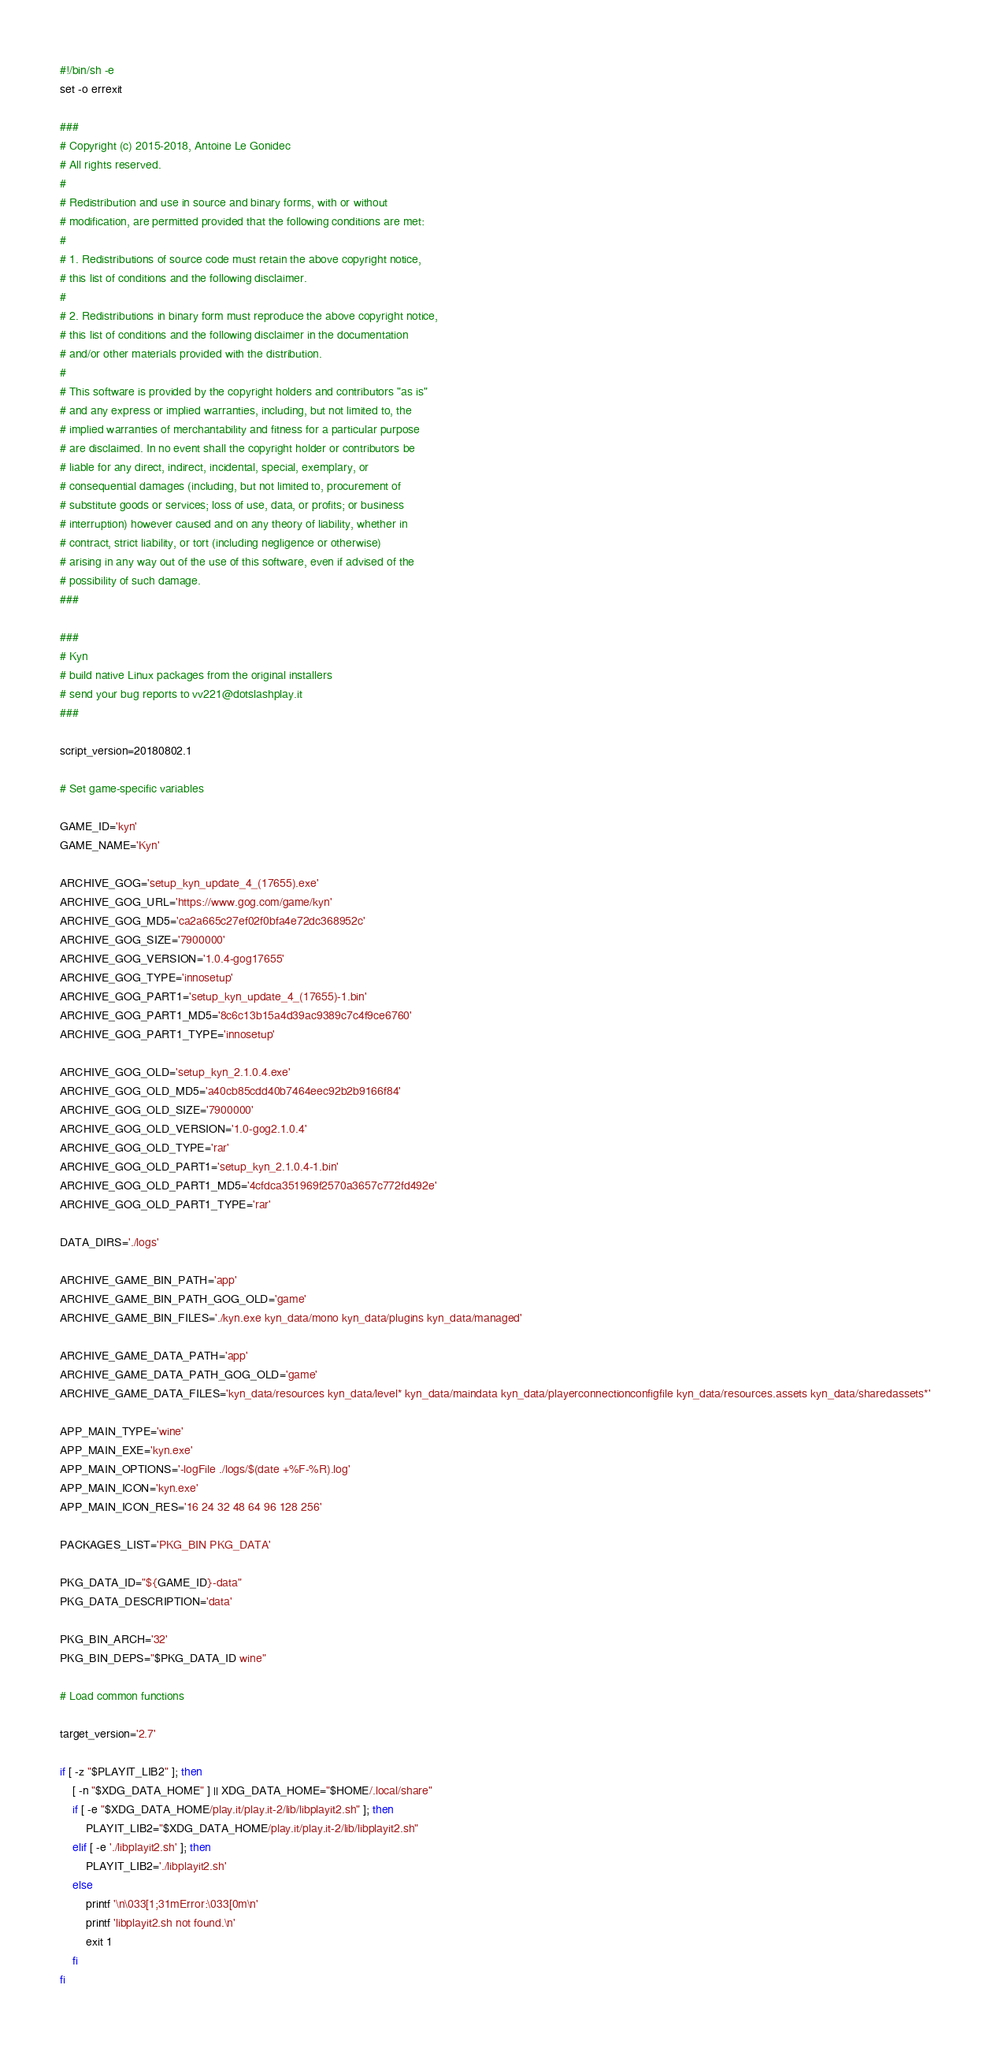<code> <loc_0><loc_0><loc_500><loc_500><_Bash_>#!/bin/sh -e
set -o errexit

###
# Copyright (c) 2015-2018, Antoine Le Gonidec
# All rights reserved.
#
# Redistribution and use in source and binary forms, with or without
# modification, are permitted provided that the following conditions are met:
#
# 1. Redistributions of source code must retain the above copyright notice,
# this list of conditions and the following disclaimer.
#
# 2. Redistributions in binary form must reproduce the above copyright notice,
# this list of conditions and the following disclaimer in the documentation
# and/or other materials provided with the distribution.
#
# This software is provided by the copyright holders and contributors "as is"
# and any express or implied warranties, including, but not limited to, the
# implied warranties of merchantability and fitness for a particular purpose
# are disclaimed. In no event shall the copyright holder or contributors be
# liable for any direct, indirect, incidental, special, exemplary, or
# consequential damages (including, but not limited to, procurement of
# substitute goods or services; loss of use, data, or profits; or business
# interruption) however caused and on any theory of liability, whether in
# contract, strict liability, or tort (including negligence or otherwise)
# arising in any way out of the use of this software, even if advised of the
# possibility of such damage.
###

###
# Kyn
# build native Linux packages from the original installers
# send your bug reports to vv221@dotslashplay.it
###

script_version=20180802.1

# Set game-specific variables

GAME_ID='kyn'
GAME_NAME='Kyn'

ARCHIVE_GOG='setup_kyn_update_4_(17655).exe'
ARCHIVE_GOG_URL='https://www.gog.com/game/kyn'
ARCHIVE_GOG_MD5='ca2a665c27ef02f0bfa4e72dc368952c'
ARCHIVE_GOG_SIZE='7900000'
ARCHIVE_GOG_VERSION='1.0.4-gog17655'
ARCHIVE_GOG_TYPE='innosetup'
ARCHIVE_GOG_PART1='setup_kyn_update_4_(17655)-1.bin'
ARCHIVE_GOG_PART1_MD5='8c6c13b15a4d39ac9389c7c4f9ce6760'
ARCHIVE_GOG_PART1_TYPE='innosetup'

ARCHIVE_GOG_OLD='setup_kyn_2.1.0.4.exe'
ARCHIVE_GOG_OLD_MD5='a40cb85cdd40b7464eec92b2b9166f84'
ARCHIVE_GOG_OLD_SIZE='7900000'
ARCHIVE_GOG_OLD_VERSION='1.0-gog2.1.0.4'
ARCHIVE_GOG_OLD_TYPE='rar'
ARCHIVE_GOG_OLD_PART1='setup_kyn_2.1.0.4-1.bin'
ARCHIVE_GOG_OLD_PART1_MD5='4cfdca351969f2570a3657c772fd492e'
ARCHIVE_GOG_OLD_PART1_TYPE='rar'

DATA_DIRS='./logs'

ARCHIVE_GAME_BIN_PATH='app'
ARCHIVE_GAME_BIN_PATH_GOG_OLD='game'
ARCHIVE_GAME_BIN_FILES='./kyn.exe kyn_data/mono kyn_data/plugins kyn_data/managed'

ARCHIVE_GAME_DATA_PATH='app'
ARCHIVE_GAME_DATA_PATH_GOG_OLD='game'
ARCHIVE_GAME_DATA_FILES='kyn_data/resources kyn_data/level* kyn_data/maindata kyn_data/playerconnectionconfigfile kyn_data/resources.assets kyn_data/sharedassets*'

APP_MAIN_TYPE='wine'
APP_MAIN_EXE='kyn.exe'
APP_MAIN_OPTIONS='-logFile ./logs/$(date +%F-%R).log'
APP_MAIN_ICON='kyn.exe'
APP_MAIN_ICON_RES='16 24 32 48 64 96 128 256'

PACKAGES_LIST='PKG_BIN PKG_DATA'

PKG_DATA_ID="${GAME_ID}-data"
PKG_DATA_DESCRIPTION='data'

PKG_BIN_ARCH='32'
PKG_BIN_DEPS="$PKG_DATA_ID wine"

# Load common functions

target_version='2.7'

if [ -z "$PLAYIT_LIB2" ]; then
	[ -n "$XDG_DATA_HOME" ] || XDG_DATA_HOME="$HOME/.local/share"
	if [ -e "$XDG_DATA_HOME/play.it/play.it-2/lib/libplayit2.sh" ]; then
		PLAYIT_LIB2="$XDG_DATA_HOME/play.it/play.it-2/lib/libplayit2.sh"
	elif [ -e './libplayit2.sh' ]; then
		PLAYIT_LIB2='./libplayit2.sh'
	else
		printf '\n\033[1;31mError:\033[0m\n'
		printf 'libplayit2.sh not found.\n'
		exit 1
	fi
fi</code> 